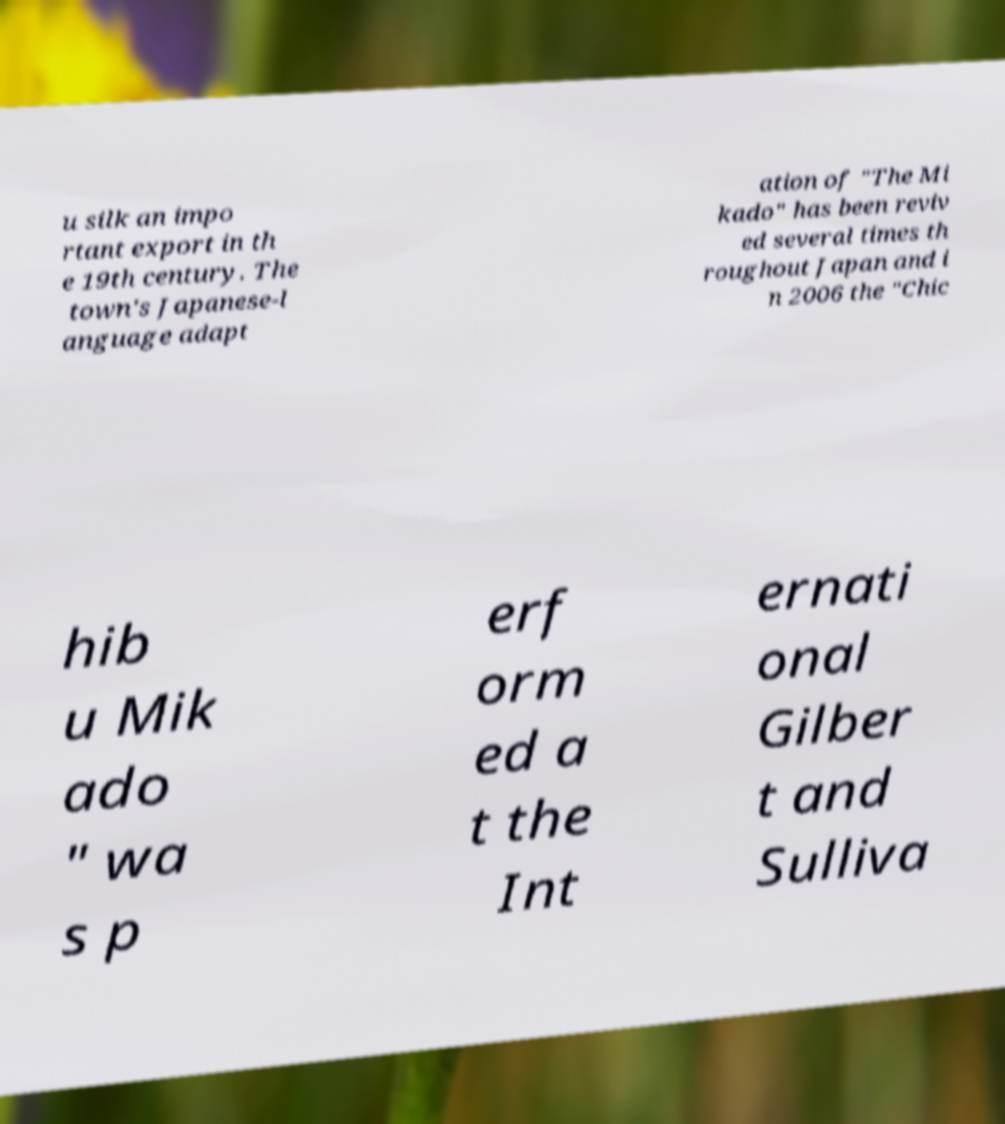Can you accurately transcribe the text from the provided image for me? u silk an impo rtant export in th e 19th century. The town's Japanese-l anguage adapt ation of "The Mi kado" has been reviv ed several times th roughout Japan and i n 2006 the "Chic hib u Mik ado " wa s p erf orm ed a t the Int ernati onal Gilber t and Sulliva 